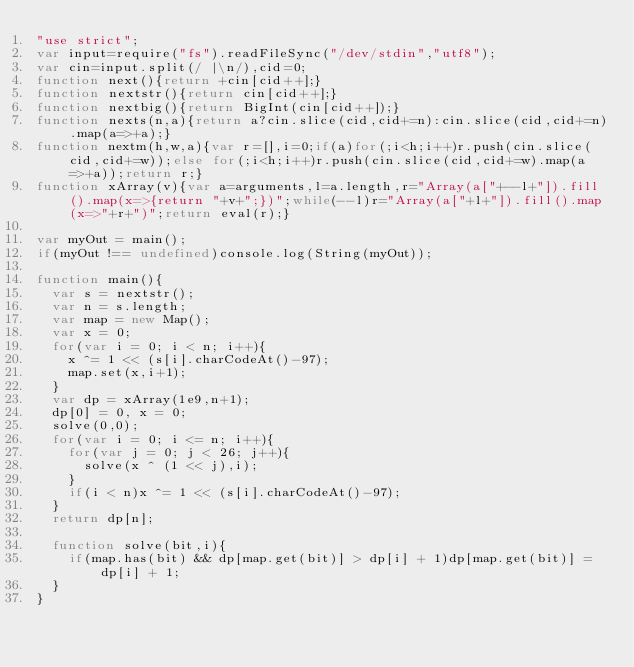Convert code to text. <code><loc_0><loc_0><loc_500><loc_500><_JavaScript_>"use strict";
var input=require("fs").readFileSync("/dev/stdin","utf8");
var cin=input.split(/ |\n/),cid=0;
function next(){return +cin[cid++];}
function nextstr(){return cin[cid++];}
function nextbig(){return BigInt(cin[cid++]);}
function nexts(n,a){return a?cin.slice(cid,cid+=n):cin.slice(cid,cid+=n).map(a=>+a);}
function nextm(h,w,a){var r=[],i=0;if(a)for(;i<h;i++)r.push(cin.slice(cid,cid+=w));else for(;i<h;i++)r.push(cin.slice(cid,cid+=w).map(a=>+a));return r;}
function xArray(v){var a=arguments,l=a.length,r="Array(a["+--l+"]).fill().map(x=>{return "+v+";})";while(--l)r="Array(a["+l+"]).fill().map(x=>"+r+")";return eval(r);}

var myOut = main();
if(myOut !== undefined)console.log(String(myOut));

function main(){
  var s = nextstr();
  var n = s.length;
  var map = new Map();
  var x = 0;
  for(var i = 0; i < n; i++){
    x ^= 1 << (s[i].charCodeAt()-97);
    map.set(x,i+1);
  }
  var dp = xArray(1e9,n+1);
  dp[0] = 0, x = 0;
  solve(0,0);
  for(var i = 0; i <= n; i++){
    for(var j = 0; j < 26; j++){
      solve(x ^ (1 << j),i);
    }
    if(i < n)x ^= 1 << (s[i].charCodeAt()-97);
  }
  return dp[n];

  function solve(bit,i){
    if(map.has(bit) && dp[map.get(bit)] > dp[i] + 1)dp[map.get(bit)] = dp[i] + 1;
  }
}</code> 